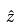Convert formula to latex. <formula><loc_0><loc_0><loc_500><loc_500>\hat { z }</formula> 